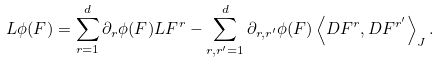Convert formula to latex. <formula><loc_0><loc_0><loc_500><loc_500>L \phi ( F ) = \sum _ { r = 1 } ^ { d } \partial _ { r } \phi ( F ) L F ^ { r } - \sum _ { r , r ^ { \prime } = 1 } ^ { d } \partial _ { r , r ^ { \prime } } \phi ( F ) \left \langle D F ^ { r } , D F ^ { r ^ { \prime } } \right \rangle _ { J } .</formula> 